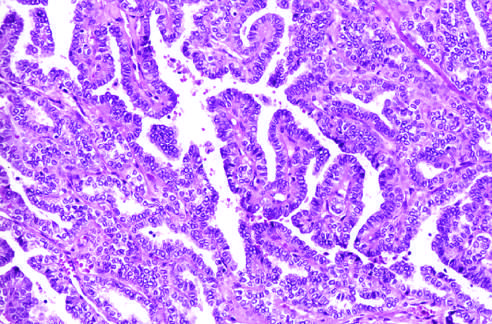s reversible injury lined by cells with characteristic empty-appearing nuclei, sometimes termed orphan annie eye nuclei c in this particular example?
Answer the question using a single word or phrase. No 